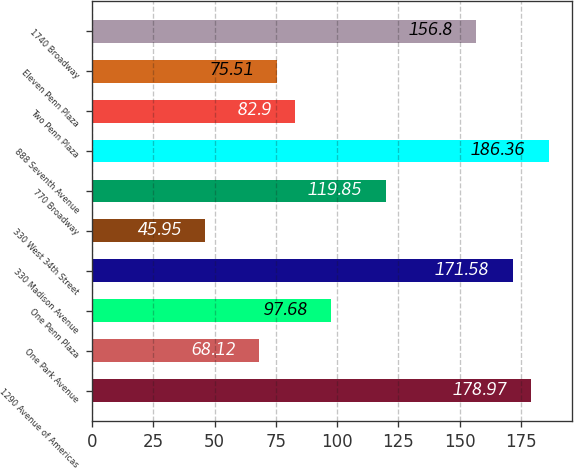Convert chart to OTSL. <chart><loc_0><loc_0><loc_500><loc_500><bar_chart><fcel>1290 Avenue of Americas<fcel>One Park Avenue<fcel>One Penn Plaza<fcel>330 Madison Avenue<fcel>330 West 34th Street<fcel>770 Broadway<fcel>888 Seventh Avenue<fcel>Two Penn Plaza<fcel>Eleven Penn Plaza<fcel>1740 Broadway<nl><fcel>178.97<fcel>68.12<fcel>97.68<fcel>171.58<fcel>45.95<fcel>119.85<fcel>186.36<fcel>82.9<fcel>75.51<fcel>156.8<nl></chart> 